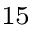<formula> <loc_0><loc_0><loc_500><loc_500>^ { 1 5 }</formula> 